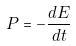<formula> <loc_0><loc_0><loc_500><loc_500>P = - \frac { d E } { d t }</formula> 